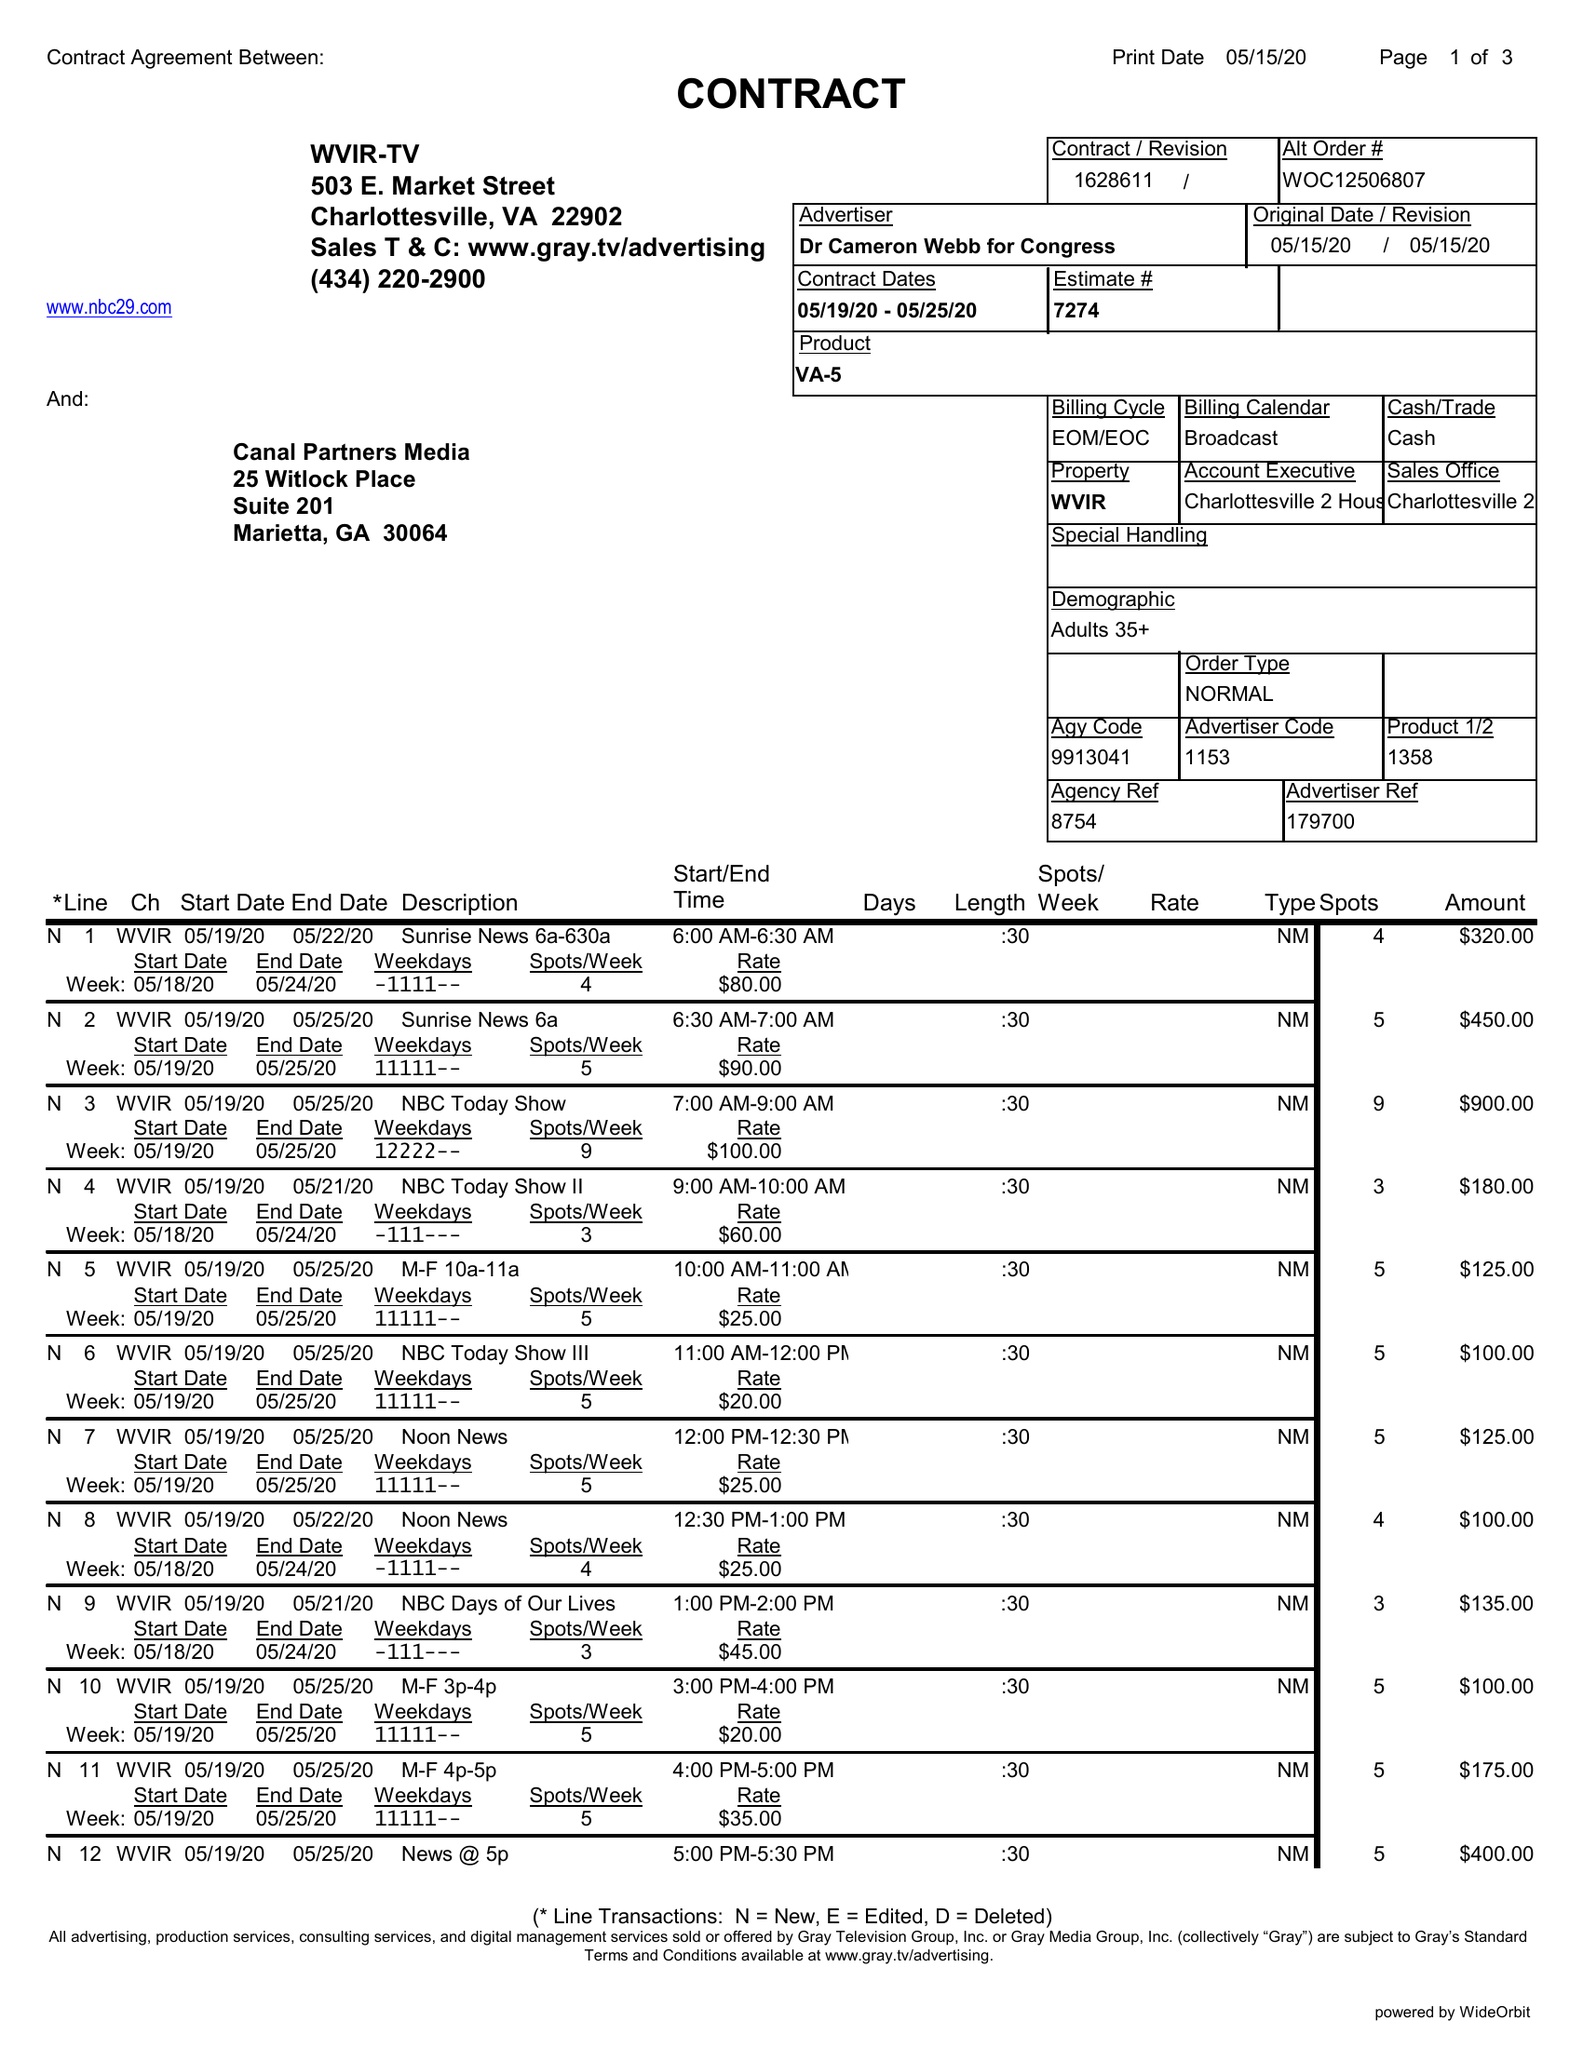What is the value for the advertiser?
Answer the question using a single word or phrase. DR CAMERON WEBB FOR CONGRESS 